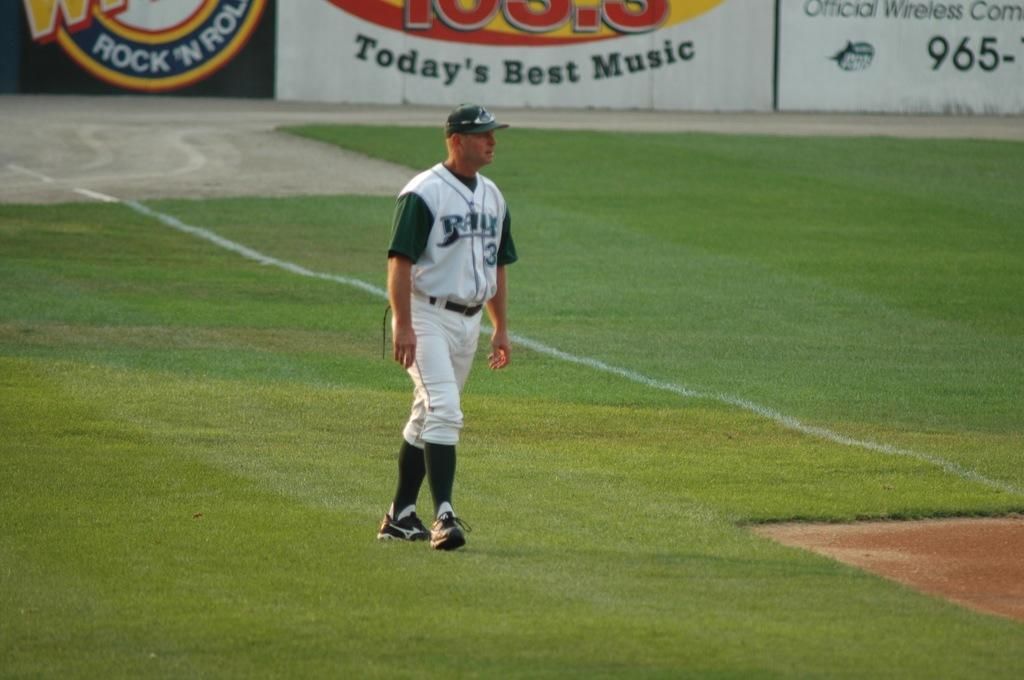Who is present in the image? There is a man in the image. What is the man wearing on his head? The man is wearing a cap. What type of footwear is the man wearing? The man is wearing shoes. What is the man doing in the image? The man is walking on the grass. What can be seen in the background of the image? There are posters in the background of the image. How many birds are sitting on the man's shoulder in the image? There are no birds present in the image, so it is not possible to determine the number of birds on the man's shoulder. 